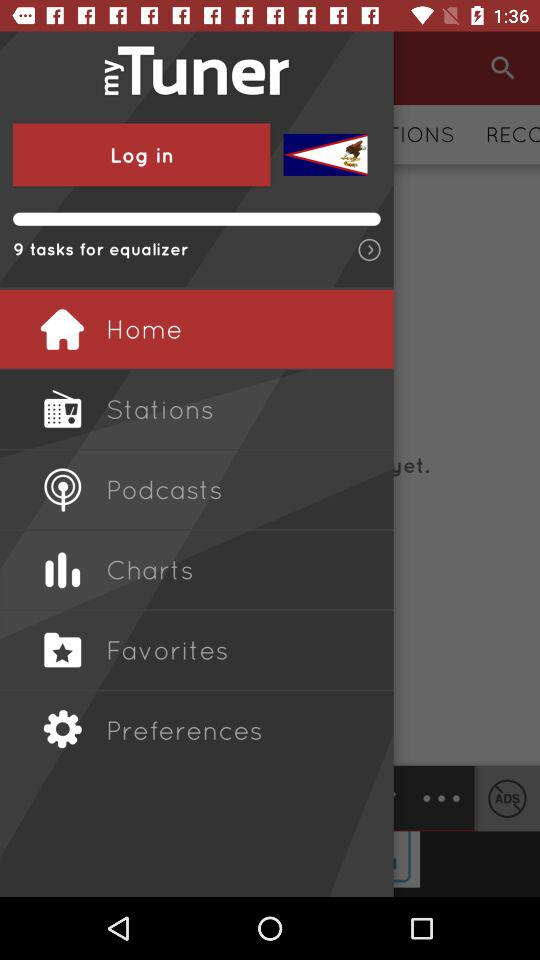How many tasks are for the equalizer? There are 9 tasks for the equalizer. 